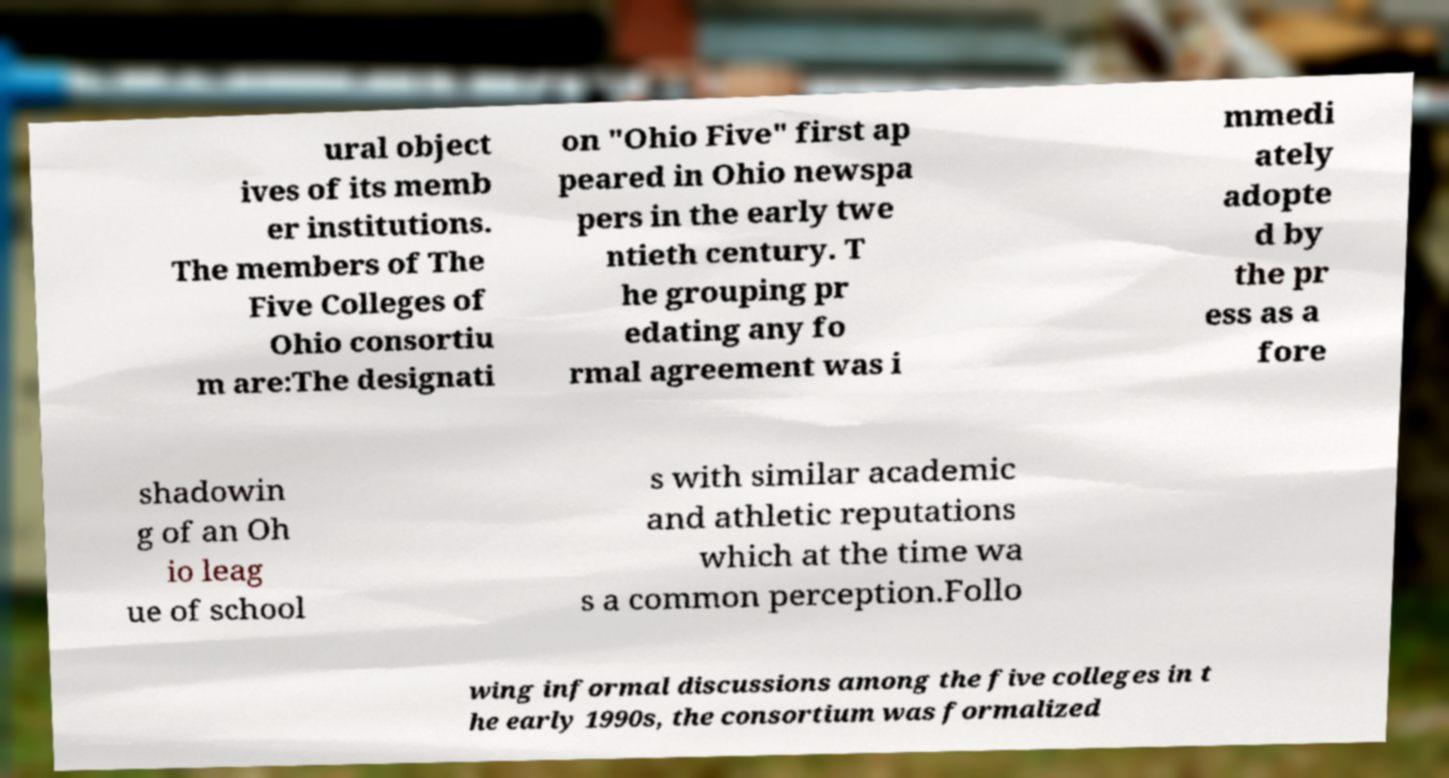What messages or text are displayed in this image? I need them in a readable, typed format. ural object ives of its memb er institutions. The members of The Five Colleges of Ohio consortiu m are:The designati on "Ohio Five" first ap peared in Ohio newspa pers in the early twe ntieth century. T he grouping pr edating any fo rmal agreement was i mmedi ately adopte d by the pr ess as a fore shadowin g of an Oh io leag ue of school s with similar academic and athletic reputations which at the time wa s a common perception.Follo wing informal discussions among the five colleges in t he early 1990s, the consortium was formalized 